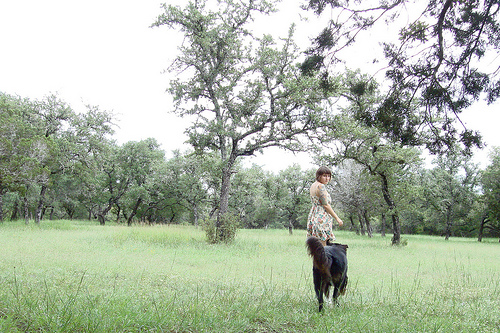<image>
Can you confirm if the girl is on the dog? No. The girl is not positioned on the dog. They may be near each other, but the girl is not supported by or resting on top of the dog. Where is the tree in relation to the woman? Is it to the left of the woman? Yes. From this viewpoint, the tree is positioned to the left side relative to the woman. Is the woman in front of the dog? Yes. The woman is positioned in front of the dog, appearing closer to the camera viewpoint. 